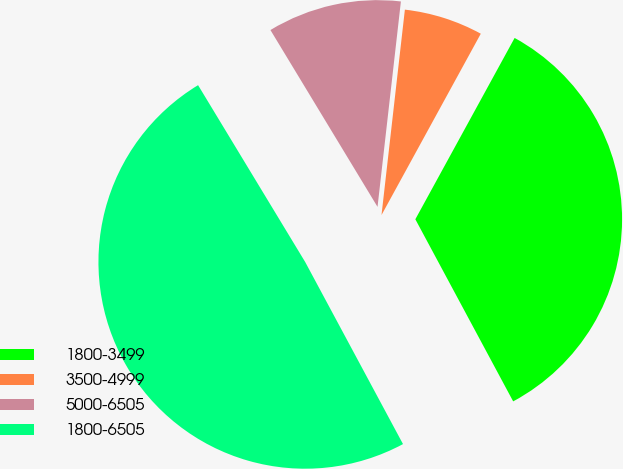Convert chart to OTSL. <chart><loc_0><loc_0><loc_500><loc_500><pie_chart><fcel>1800-3499<fcel>3500-4999<fcel>5000-6505<fcel>1800-6505<nl><fcel>34.18%<fcel>6.17%<fcel>10.47%<fcel>49.18%<nl></chart> 